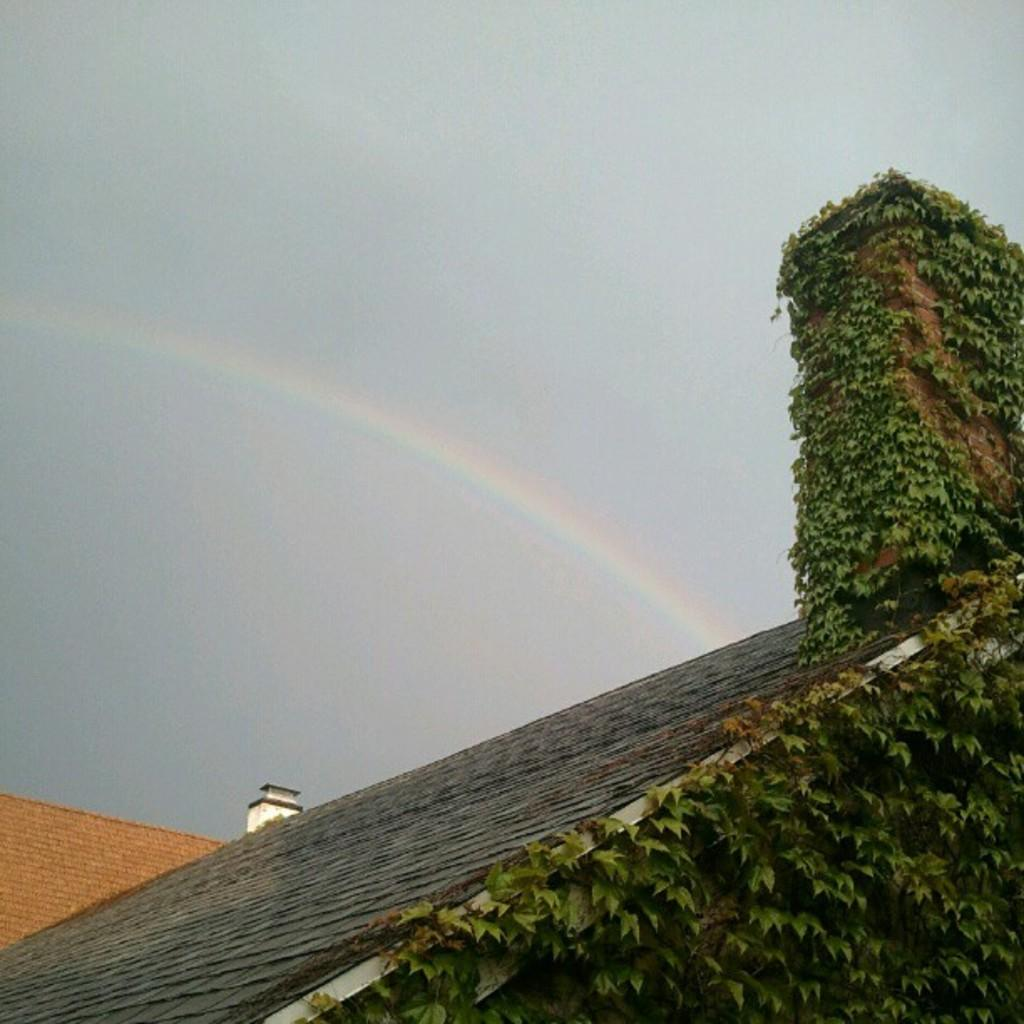What type of location is depicted in the image? The image appears to be a building roof. What type of vegetation can be seen on the roof? There are creepers visible on the roof. What can be seen in the sky in the image? There is a rainbow in the sky. How many pets are visible on the roof in the image? There are no pets visible on the roof in the image. What type of distribution system is present on the roof in the image? There is no distribution system present on the roof in the image. 